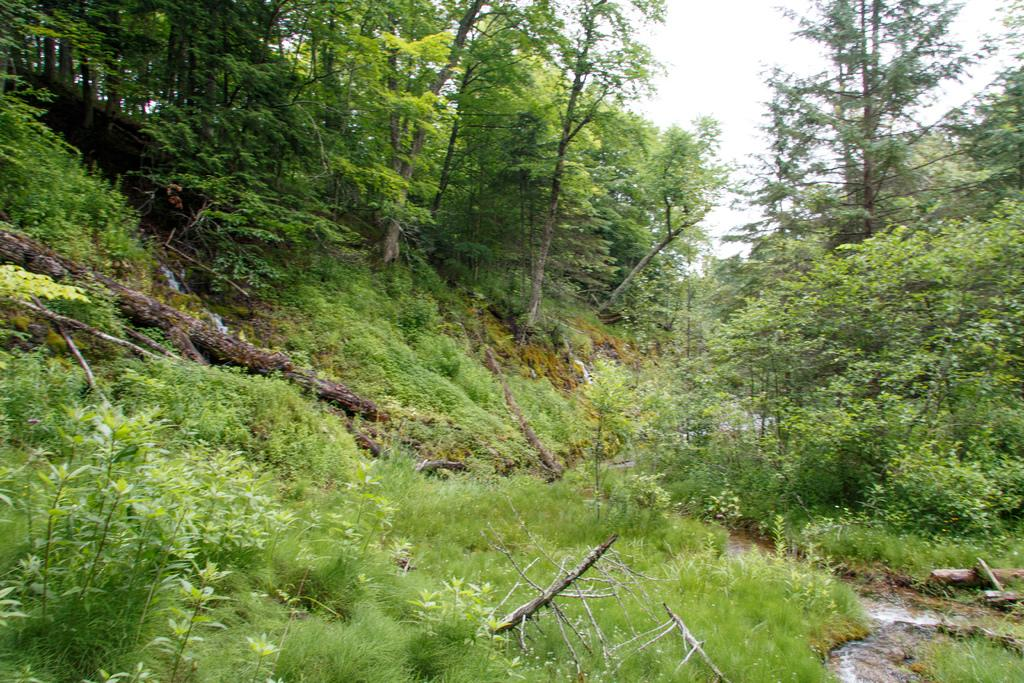What type of vegetation covers the land in the image? The land in the image is covered with plants. Can you describe the trees in the image? Trees are present all over the place in the image. What part of the natural environment is visible in the image? The sky is visible in the image. How many hooks can be seen hanging from the trees in the image? There are no hooks visible in the image; it features plants and trees with no mention of hooks. 